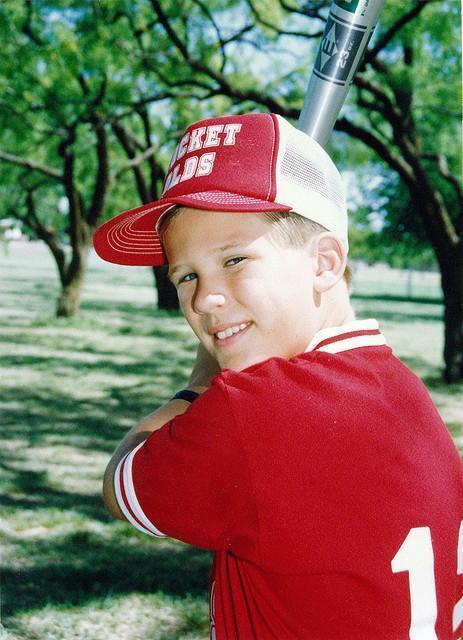How many baseball bats are there?
Give a very brief answer. 1. How many giraffes are there in the grass?
Give a very brief answer. 0. 